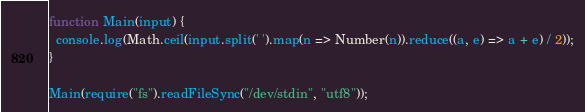<code> <loc_0><loc_0><loc_500><loc_500><_JavaScript_>function Main(input) {
  console.log(Math.ceil(input.split(' ').map(n => Number(n)).reduce((a, e) => a + e) / 2));
}

Main(require("fs").readFileSync("/dev/stdin", "utf8"));</code> 